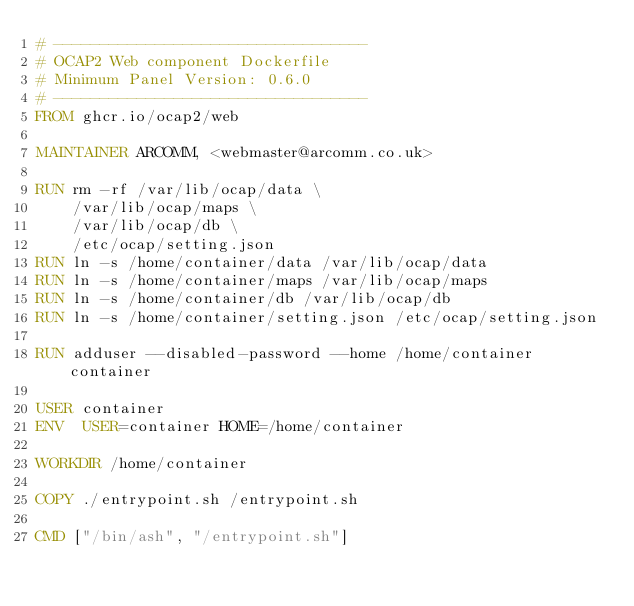Convert code to text. <code><loc_0><loc_0><loc_500><loc_500><_Dockerfile_># ----------------------------------
# OCAP2 Web component Dockerfile
# Minimum Panel Version: 0.6.0
# ----------------------------------
FROM ghcr.io/ocap2/web

MAINTAINER ARCOMM, <webmaster@arcomm.co.uk>

RUN rm -rf /var/lib/ocap/data \
    /var/lib/ocap/maps \
    /var/lib/ocap/db \
    /etc/ocap/setting.json
RUN ln -s /home/container/data /var/lib/ocap/data
RUN ln -s /home/container/maps /var/lib/ocap/maps
RUN ln -s /home/container/db /var/lib/ocap/db
RUN ln -s /home/container/setting.json /etc/ocap/setting.json

RUN adduser --disabled-password --home /home/container container

USER container
ENV  USER=container HOME=/home/container

WORKDIR /home/container

COPY ./entrypoint.sh /entrypoint.sh

CMD ["/bin/ash", "/entrypoint.sh"]</code> 